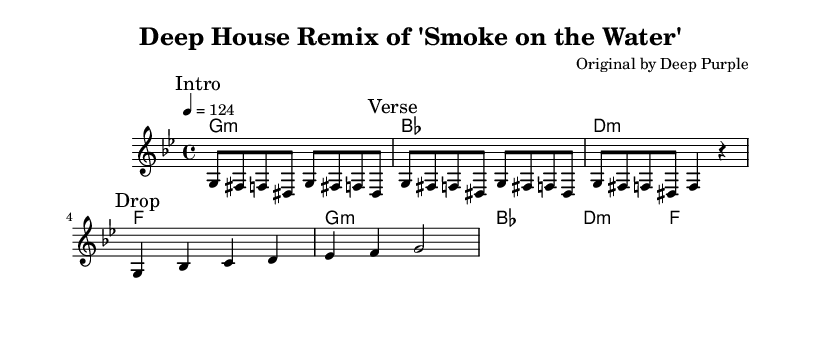What is the key signature of this music? The key signature is G minor, which contains two flats (B♭ and E♭). This is identified by the presence of the G note in the key signature and the other notes around it.
Answer: G minor What is the time signature of this music? The time signature is 4/4, indicated at the beginning of the score. This means there are four beats in each measure and a quarter note receives one beat.
Answer: 4/4 What is the tempo marking of the piece? The tempo marking is 124 beats per minute, stated at the beginning of the score with the indication "4 = 124". This indicates the speed of the music.
Answer: 124 How many measures are in the drop section? The drop section consists of two measures. This can be determined by counting the measures specifically marked "Drop" in the sheet music.
Answer: 2 What is the first chord of the harmony? The first chord is G minor. This is noted in the chord names section, where the first chord listed corresponds with the key signature and melody of the piece.
Answer: G:m In which section does the melody repeat its main theme? The melody repeats its main theme in the "Verse" section. This is identifiable as the melody played in the verse matches the melody in the introductory section.
Answer: Verse What style of music is this piece arranged in? This piece is arranged in Deep House style. This can be inferred due to the remix aspect of a classic rock song, adapting its elements into a house music context.
Answer: Deep House 